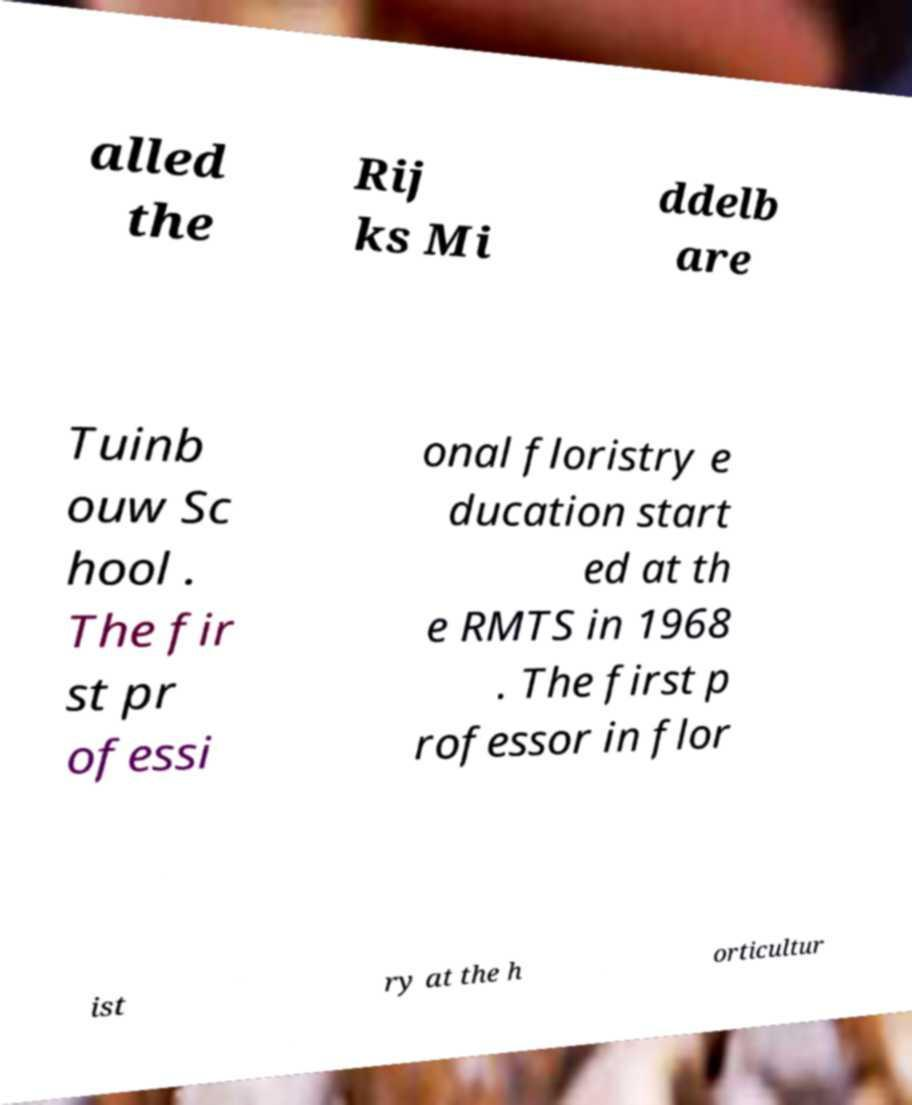For documentation purposes, I need the text within this image transcribed. Could you provide that? alled the Rij ks Mi ddelb are Tuinb ouw Sc hool . The fir st pr ofessi onal floristry e ducation start ed at th e RMTS in 1968 . The first p rofessor in flor ist ry at the h orticultur 